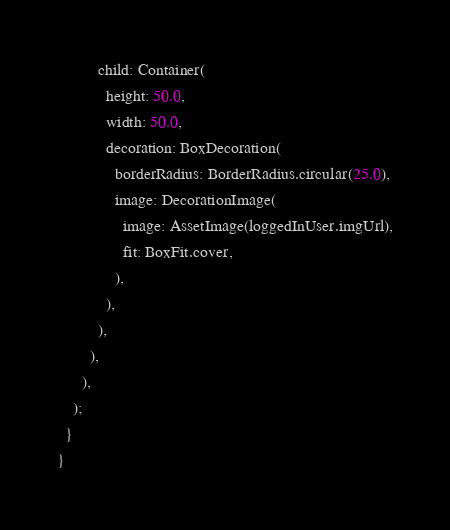<code> <loc_0><loc_0><loc_500><loc_500><_Dart_>          child: Container(
            height: 50.0,
            width: 50.0,
            decoration: BoxDecoration(
              borderRadius: BorderRadius.circular(25.0),
              image: DecorationImage(
                image: AssetImage(loggedInUser.imgUrl),
                fit: BoxFit.cover,
              ),
            ),
          ),
        ),
      ),
    );
  }
}
</code> 